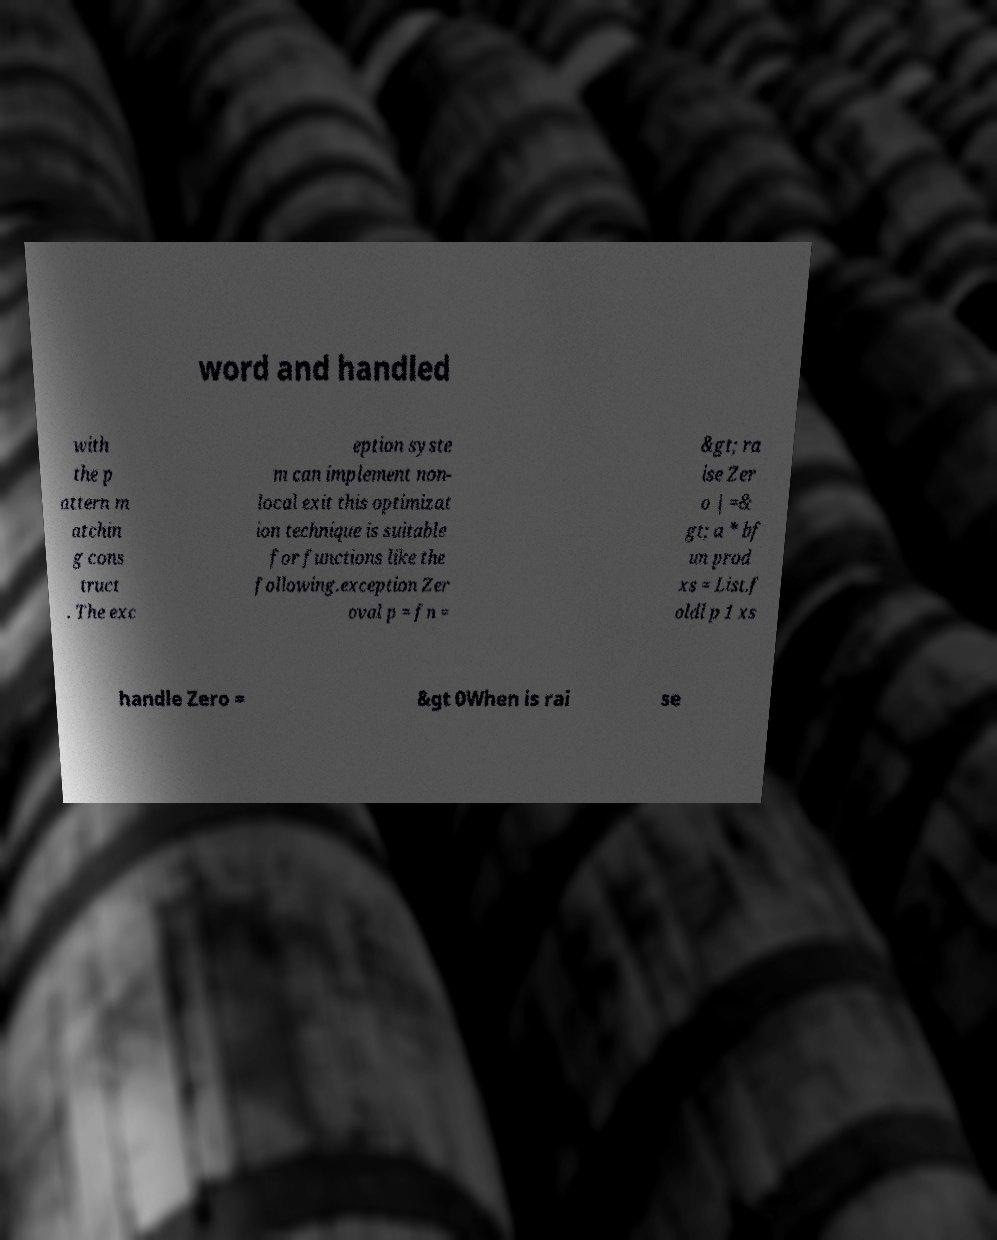For documentation purposes, I need the text within this image transcribed. Could you provide that? word and handled with the p attern m atchin g cons truct . The exc eption syste m can implement non- local exit this optimizat ion technique is suitable for functions like the following.exception Zer oval p = fn = &gt; ra ise Zer o | =& gt; a * bf un prod xs = List.f oldl p 1 xs handle Zero = &gt 0When is rai se 